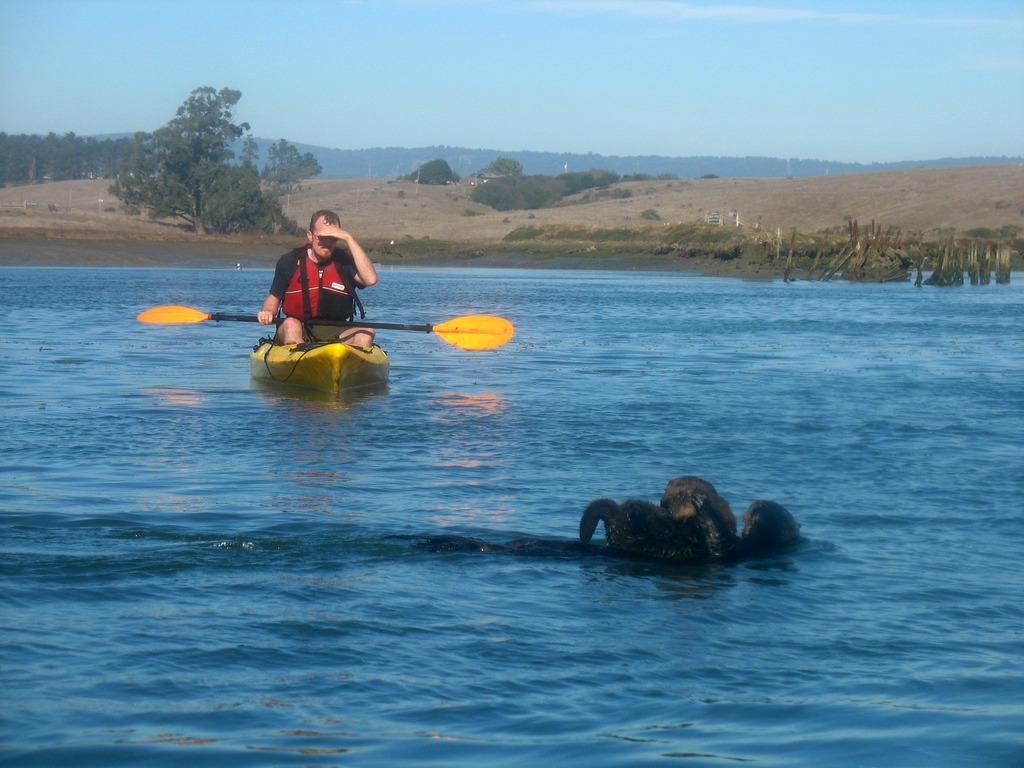How would you summarize this image in a sentence or two? In the foreground, I can see a lion and a crocodile in the water and a person is boating in the water. In the background, I can see grass, trees, fence, mountains and the sky. This image is taken, maybe near the lake. 